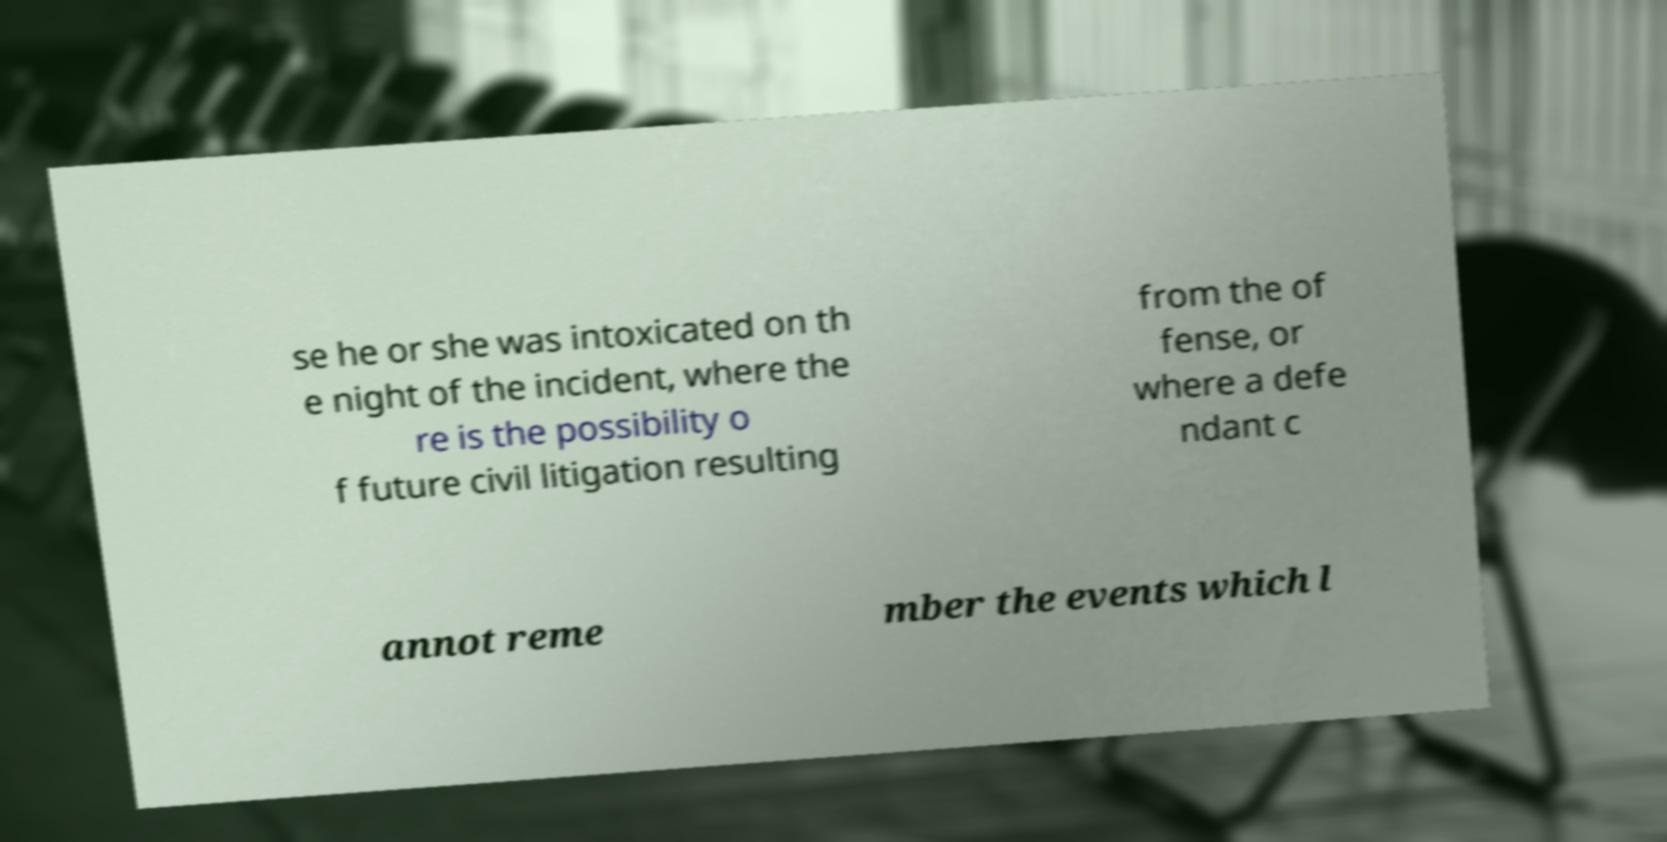Could you assist in decoding the text presented in this image and type it out clearly? se he or she was intoxicated on th e night of the incident, where the re is the possibility o f future civil litigation resulting from the of fense, or where a defe ndant c annot reme mber the events which l 